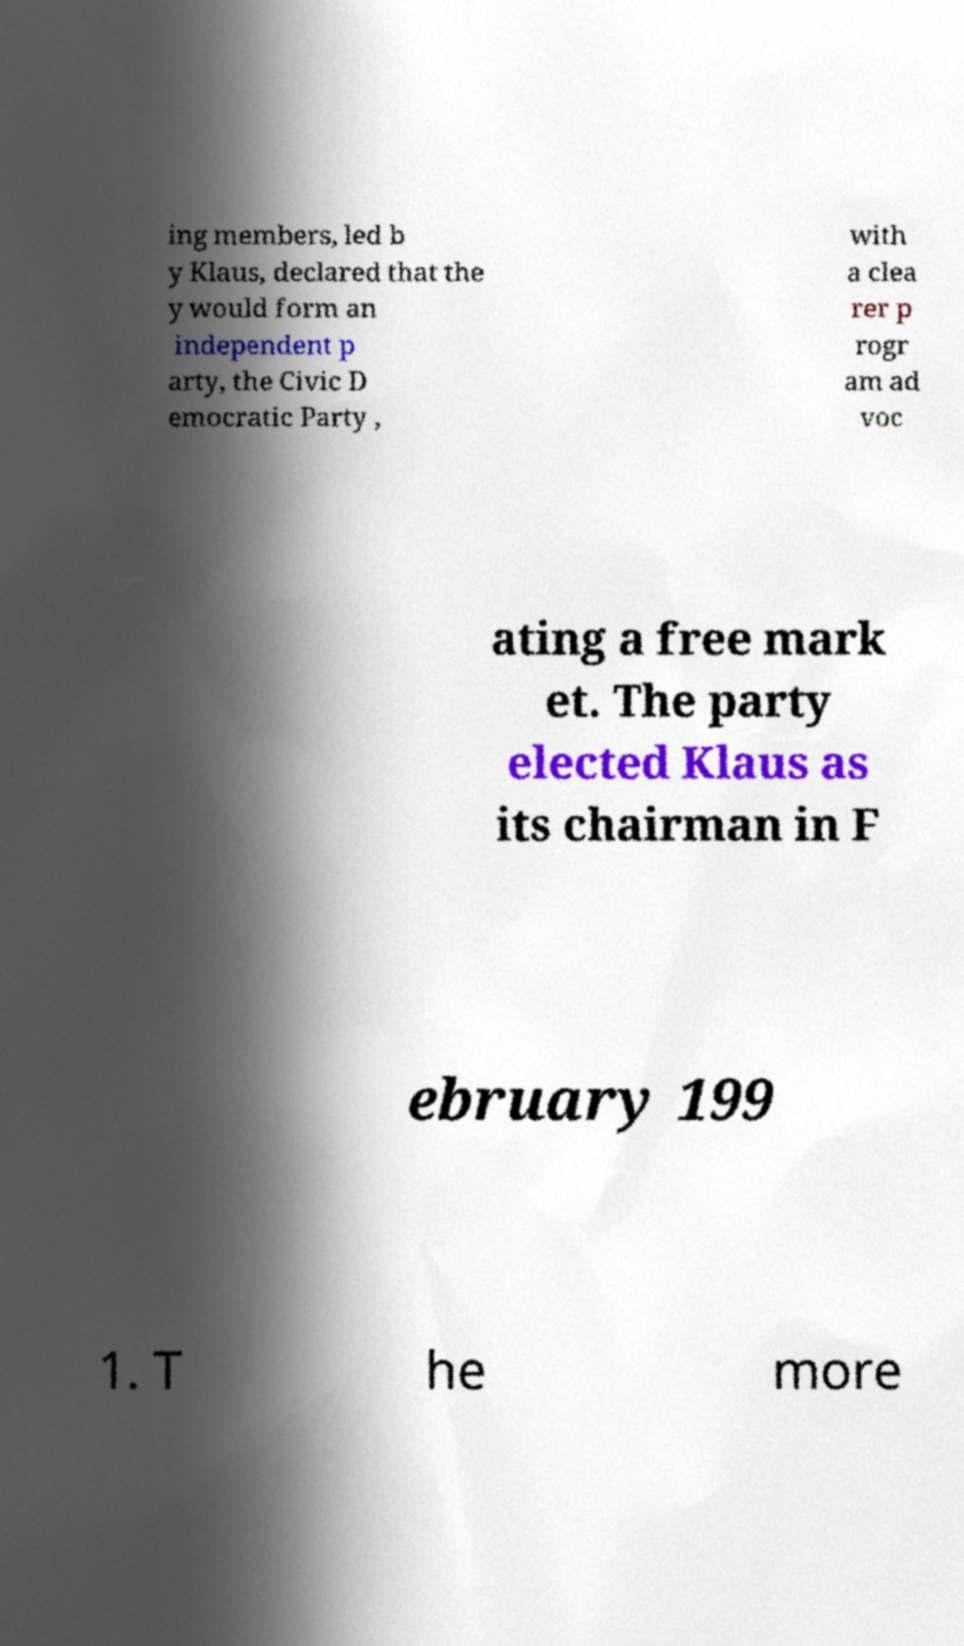Could you extract and type out the text from this image? ing members, led b y Klaus, declared that the y would form an independent p arty, the Civic D emocratic Party , with a clea rer p rogr am ad voc ating a free mark et. The party elected Klaus as its chairman in F ebruary 199 1. T he more 